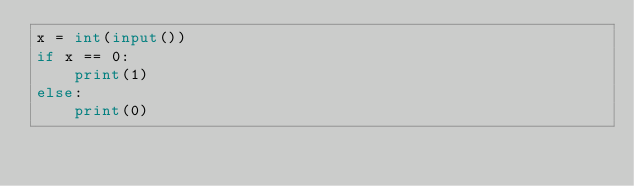<code> <loc_0><loc_0><loc_500><loc_500><_Python_>x = int(input())
if x == 0:
    print(1)
else:
    print(0)</code> 